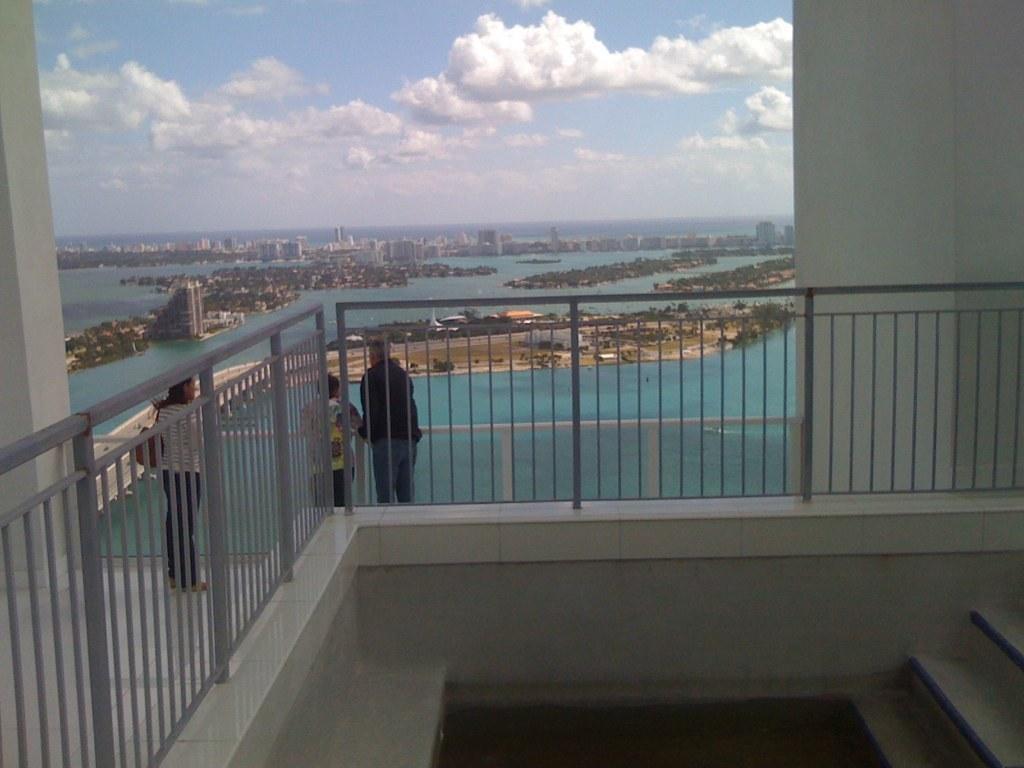Please provide a concise description of this image. In this image, we can see three people are standing near the railing. Here we can see grills. On the right side, we can see few steps. Here there is a water. Background we can see wall, pillar, so many buildings, houses, water. Top of the image, there is a sky with clouds. Here we can see so many trees. 